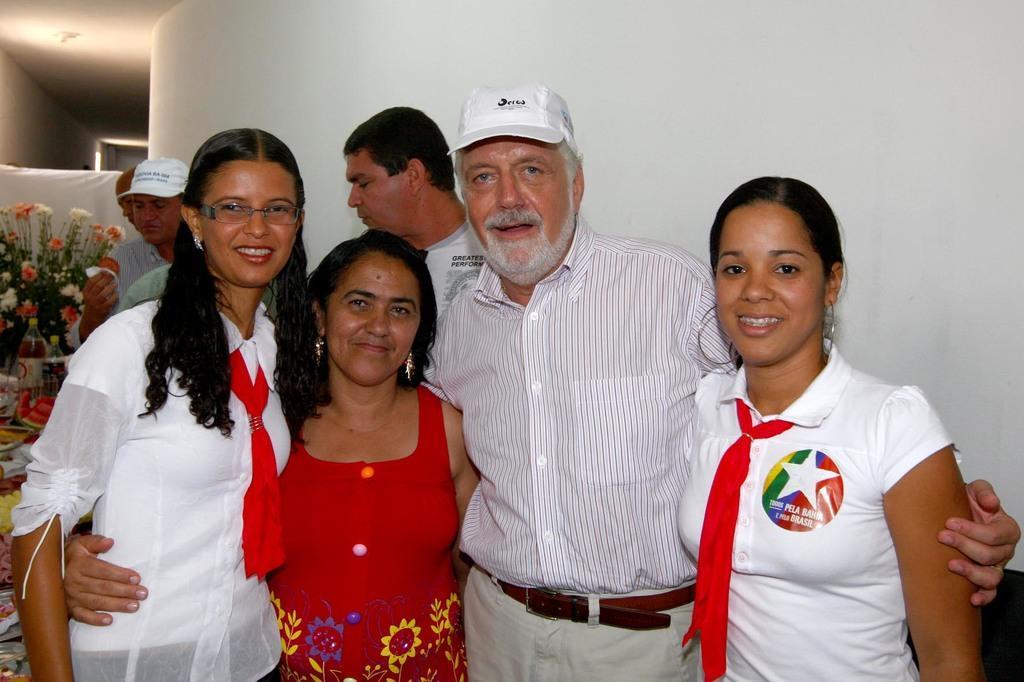Could you give a brief overview of what you see in this image? In this image we can see the people standing on the floor and one person holding a paper with a food item. At the back there is a wall. And at the side, it looks like a table, on the table there are some food items and there is a bottle, cloth and flower bogey. 